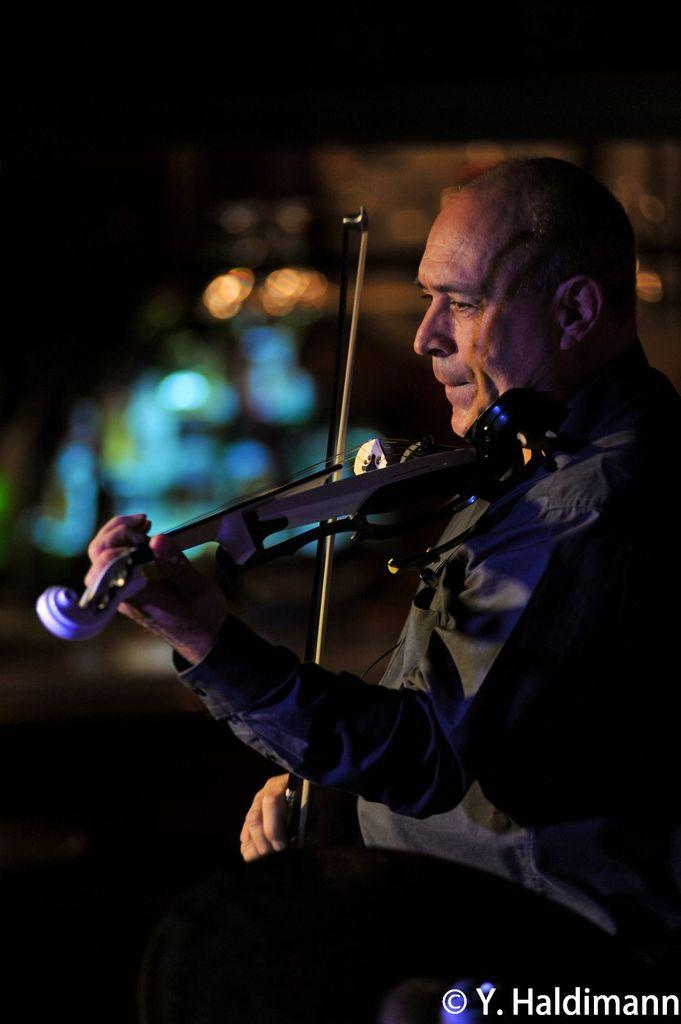Who is the main subject in the image? There is a man in the image. What is the man holding in the image? The man is holding a violin. Can you describe the background of the image? The background of the image is blurry. What type of gold jewelry can be seen on the man's wrist in the image? There is no gold jewelry visible on the man's wrist in the image. 